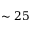<formula> <loc_0><loc_0><loc_500><loc_500>\sim 2 5</formula> 